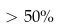<formula> <loc_0><loc_0><loc_500><loc_500>> 5 0 \%</formula> 